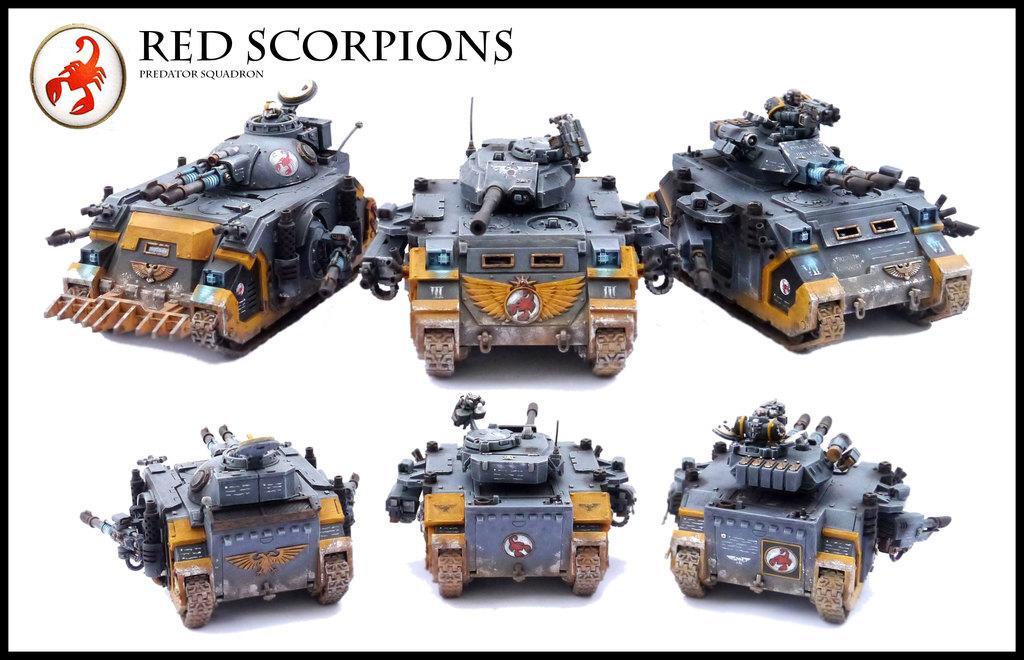Please provide a concise description of this image. In this image I see number of toy tanks which are of grey, brown and orange in color and I see the watermark over here and I see the logo over here and it is white in the background. 